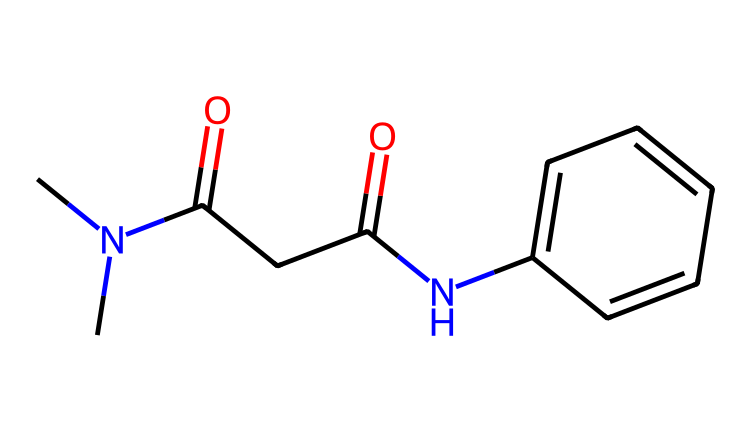What is the molecular formula of this chemical? By analyzing the SMILES representation, we can determine the number of each type of atom present. This chemical includes Carbon (C), Nitrogen (N), and Oxygen (O) atoms. Counting these gives us the molecular formula C10H12N2O2.
Answer: C10H12N2O2 How many carbon atoms are present in this structure? In the SMILES representation, each 'C' corresponds to a carbon atom. By counting, we find there are 10 carbon atoms in total.
Answer: 10 What functional groups are present in this chemical? The SMILES indicates the presence of an amide functional group (–C(=O)N–) due to 'Nc' and '-C(=O)' sections. It also has carbonyl (C=O) and aromatic (benzene) components.
Answer: amide, carbonyl What is the primary use of this chemical? This chemical structure resembles that of antituberculosis drugs, such as isoniazid, which are primarily used to treat tuberculosis.
Answer: antituberculosis How do the nitrogen atoms affect the properties of this chemical? The presence of nitrogen atoms, particularly in the amide functional group, contributes to the drug’s ability to interact with bacterial enzymes in tuberculosis treatment. It also adds to the drug's polar nature, enhancing solubility in biological systems.
Answer: enhance solubility Is this chemical hydrophilic or hydrophobic? Given the presence of polar functional groups including the amide and hydroxyl parts of the structure, this chemical is hydrophilic (water-attracting).
Answer: hydrophilic 